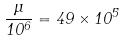Convert formula to latex. <formula><loc_0><loc_0><loc_500><loc_500>\frac { \mu } { 1 0 ^ { 6 } } = 4 9 \times 1 0 ^ { 5 }</formula> 